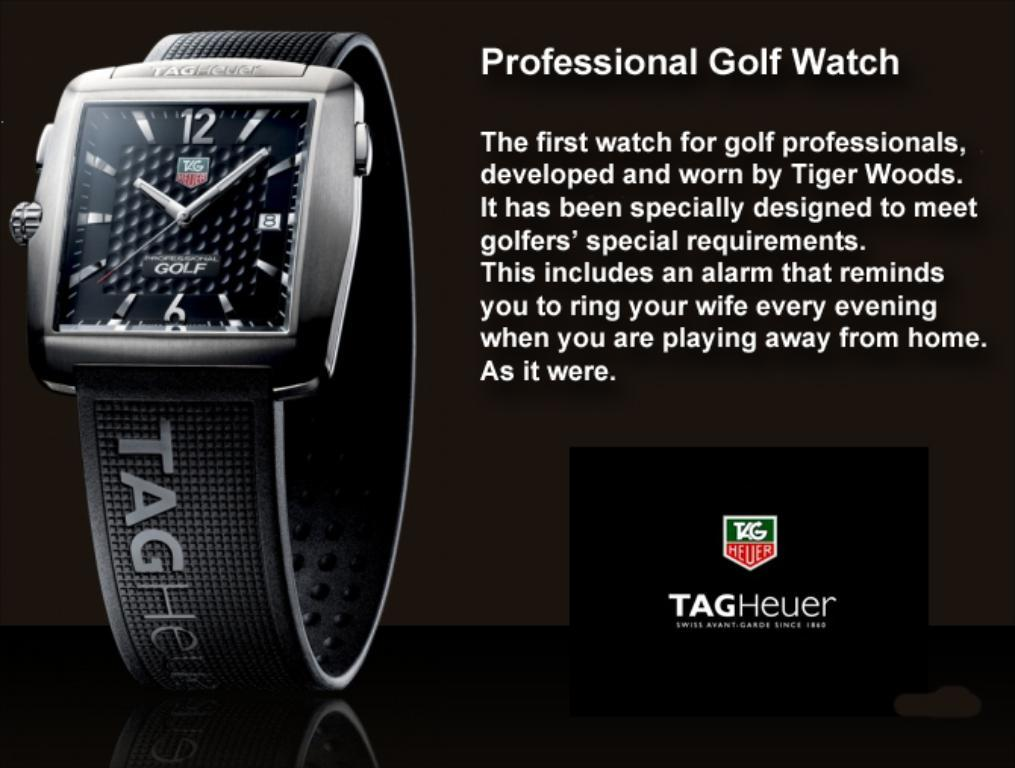<image>
Present a compact description of the photo's key features. A "Professional Golf Watch" advertisements shows a "TAGHeur" watch. 